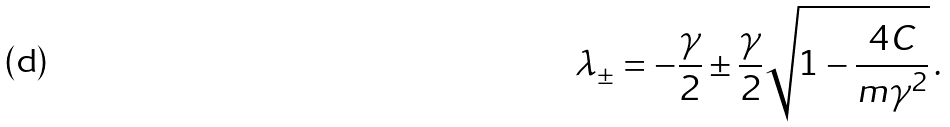Convert formula to latex. <formula><loc_0><loc_0><loc_500><loc_500>\lambda _ { \pm } = - \frac { \gamma } { 2 } \pm \frac { \gamma } { 2 } \sqrt { 1 - \frac { 4 C } { m \gamma ^ { 2 } } } \, .</formula> 